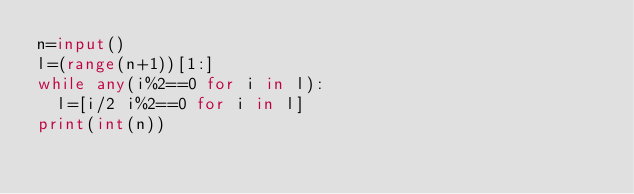<code> <loc_0><loc_0><loc_500><loc_500><_Python_>n=input()
l=(range(n+1))[1:]
while any(i%2==0 for i in l):
  l=[i/2 i%2==0 for i in l]
print(int(n))</code> 